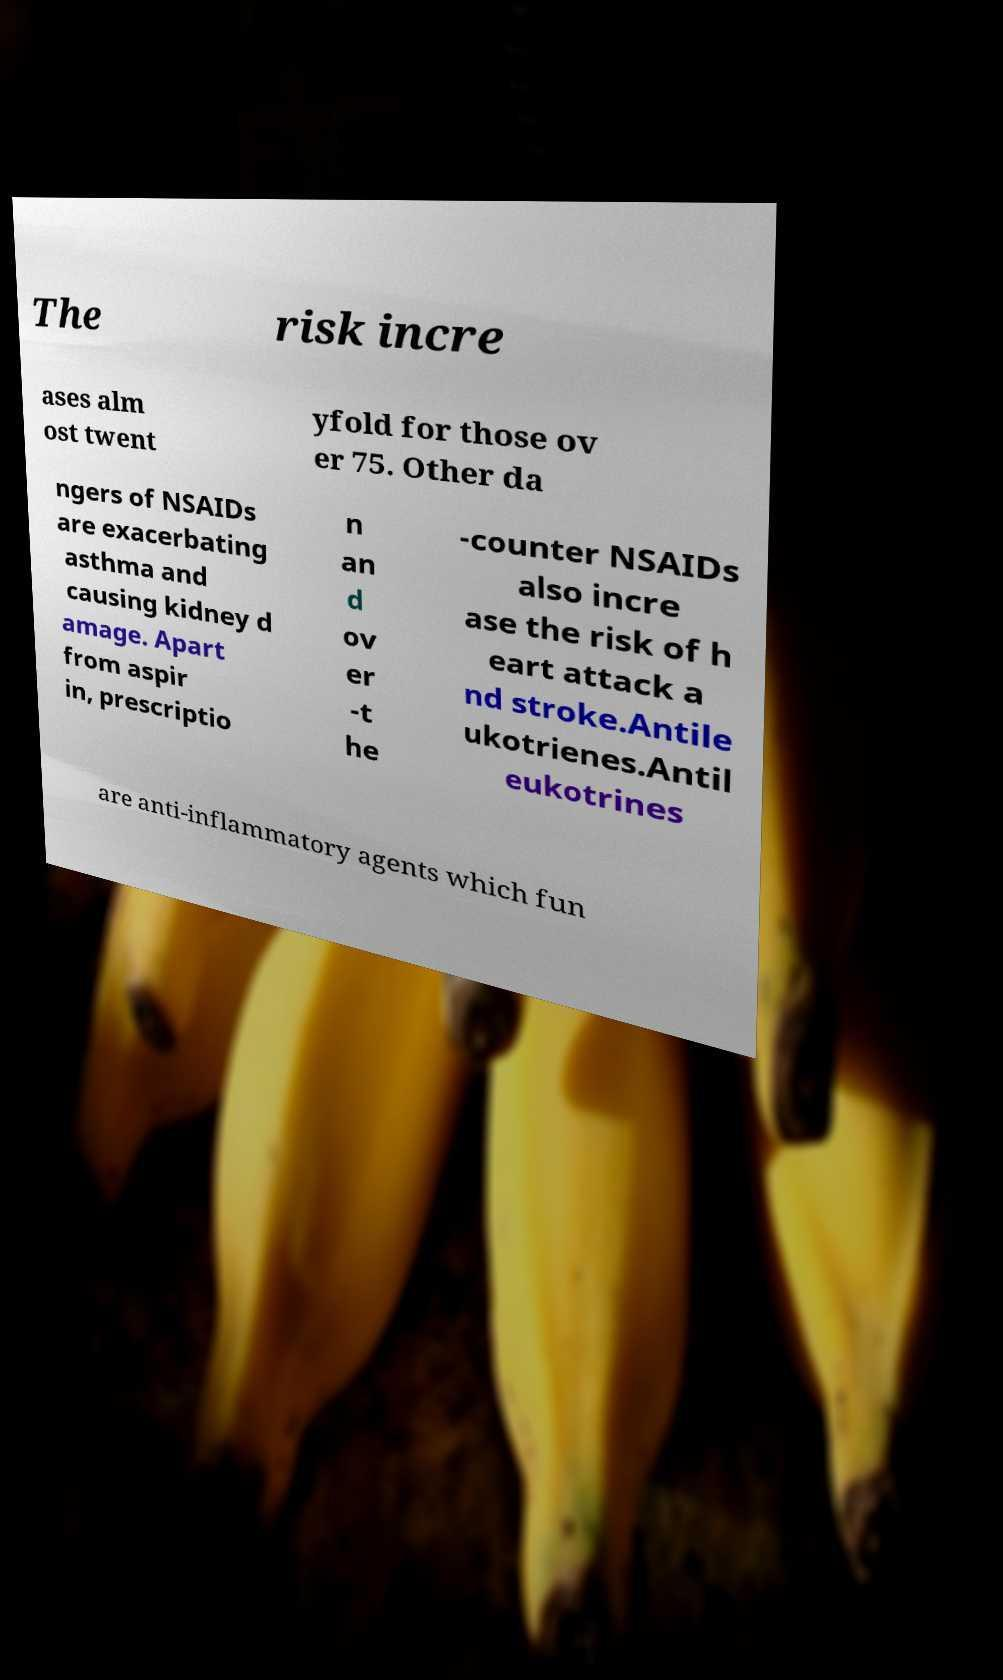Considering the information on NSAIDs, should older adults avoid these entirely? The decision for older adults to use NSAIDs should be approached with caution. As the image text underscores the increased risks, it would be prudent for older individuals to consult healthcare providers to discuss alternatives or closely monitor NSAID use, considering both the potential benefits and risks. 